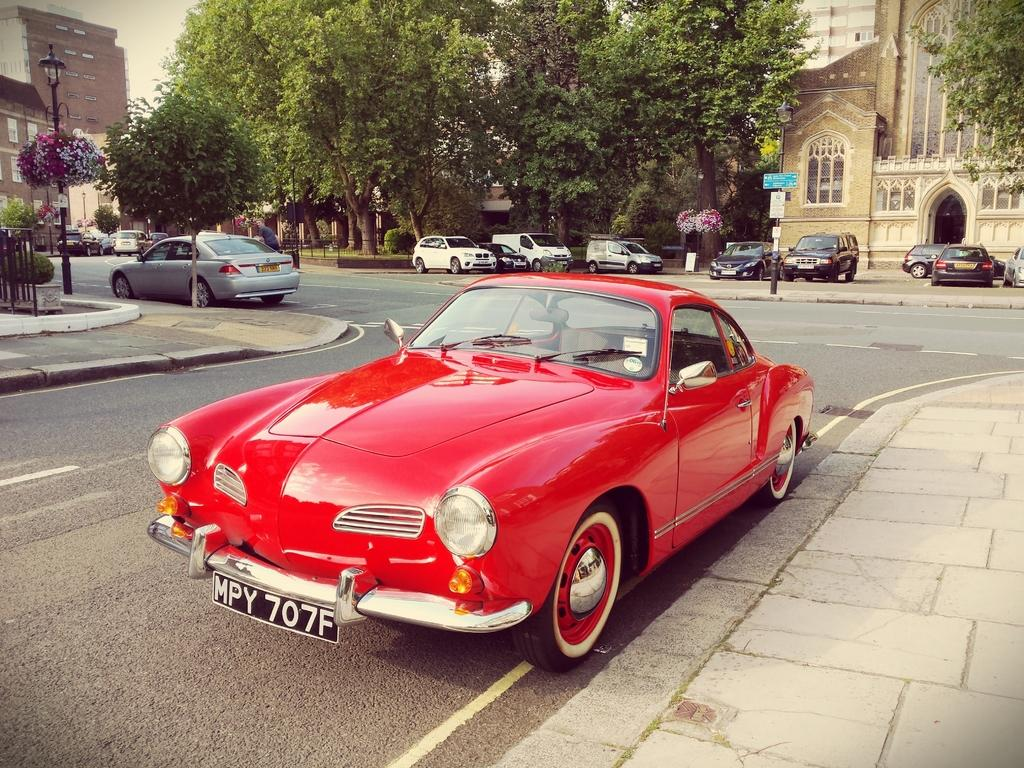What types of vehicles are present in the image? There are different colors of cars in the image. What is the tall, vertical object in the image? There is a sign pole in the image. What type of plant life can be seen in the image? There are flowers in the image. What is the source of light in the image? There is a street lamp in the image. What type of barrier is present in the image? There is a fence in the image. What type of man-made structures are present in the image? There are buildings in the image. What is visible at the top of the image? The sky is visible at the top of the image. Where is the banana located in the image? There is no banana present in the image. What type of footwear is shown on the fence in the image? There is no boot or any footwear present in the image. 